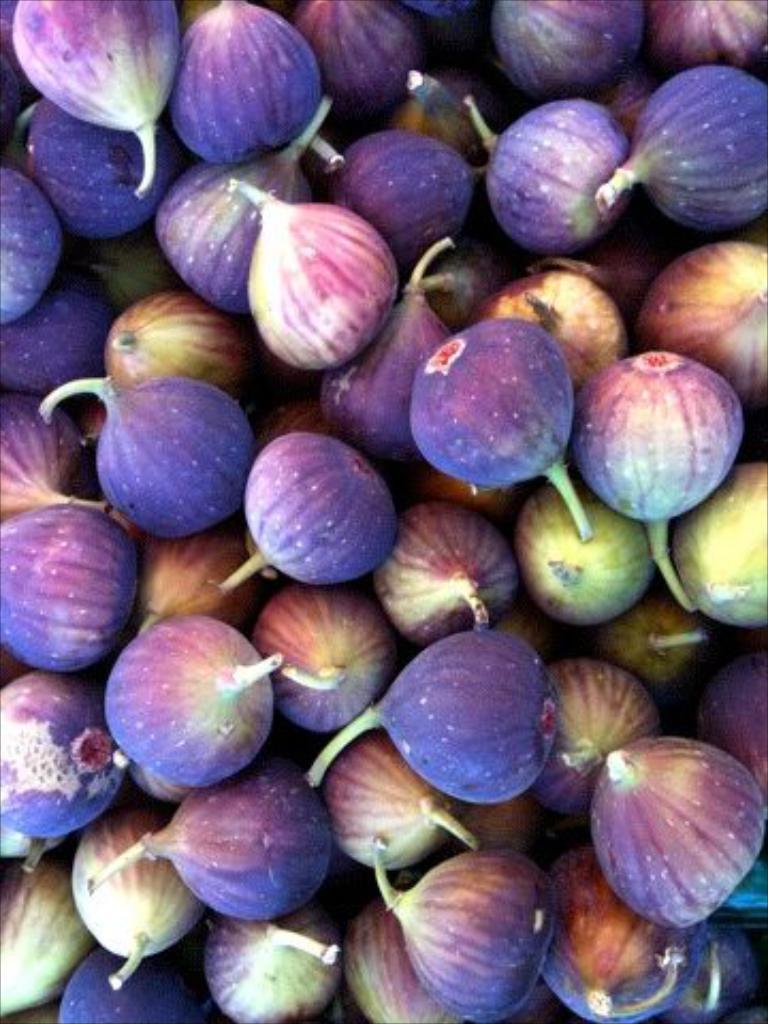Describe this image in one or two sentences. In this image I can see there are fruits in brinjal color. 